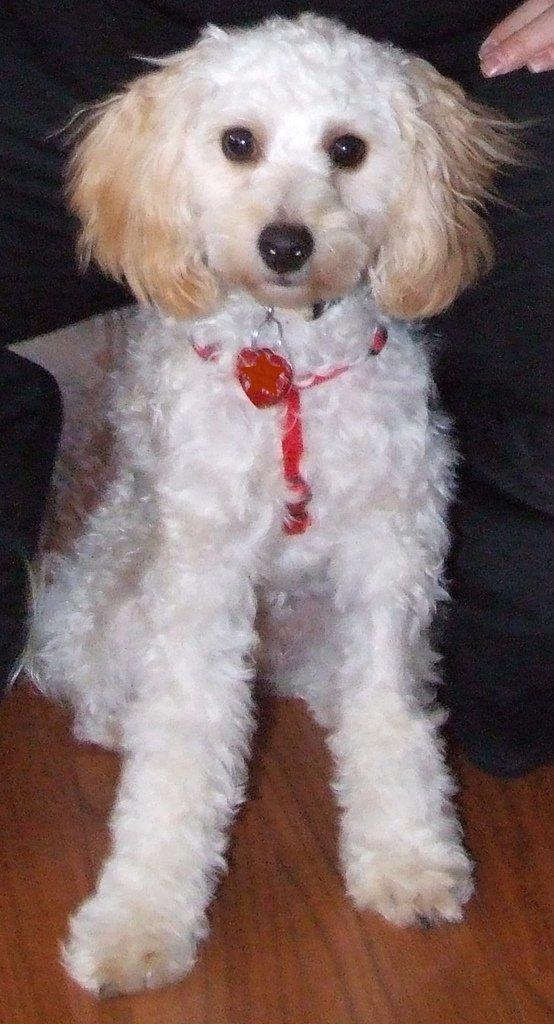What type of animal is in the image? There is a dog in the image. Can you describe the setting of the image? There is a person in the background of the image. Reasoning: Let' Let's think step by step in order to produce the conversation. We start by identifying the main subject in the image, which is the dog. Then, we expand the conversation to include the person in the background, which provides context for the setting. Each question is designed to elicit a specific detail about the image that is known from the provided facts. Absurd Question/Answer: What type of trouble is the dog causing in the image? There is no indication of trouble in the image; the dog is simply present. 